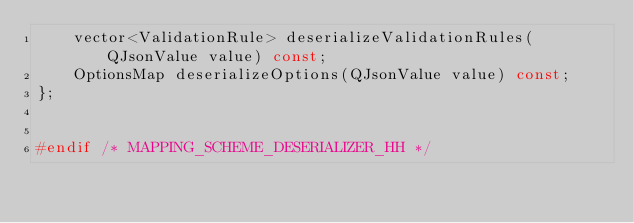<code> <loc_0><loc_0><loc_500><loc_500><_C++_>    vector<ValidationRule> deserializeValidationRules(QJsonValue value) const;
    OptionsMap deserializeOptions(QJsonValue value) const;
};


#endif /* MAPPING_SCHEME_DESERIALIZER_HH */
</code> 